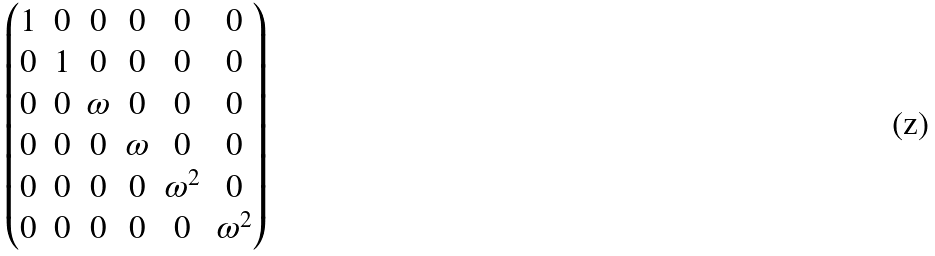Convert formula to latex. <formula><loc_0><loc_0><loc_500><loc_500>\begin{pmatrix} 1 & 0 & 0 & 0 & 0 & 0 \\ 0 & 1 & 0 & 0 & 0 & 0 \\ 0 & 0 & \omega & 0 & 0 & 0 \\ 0 & 0 & 0 & \omega & 0 & 0 \\ 0 & 0 & 0 & 0 & \omega ^ { 2 } & 0 \\ 0 & 0 & 0 & 0 & 0 & \omega ^ { 2 } \\ \end{pmatrix}</formula> 